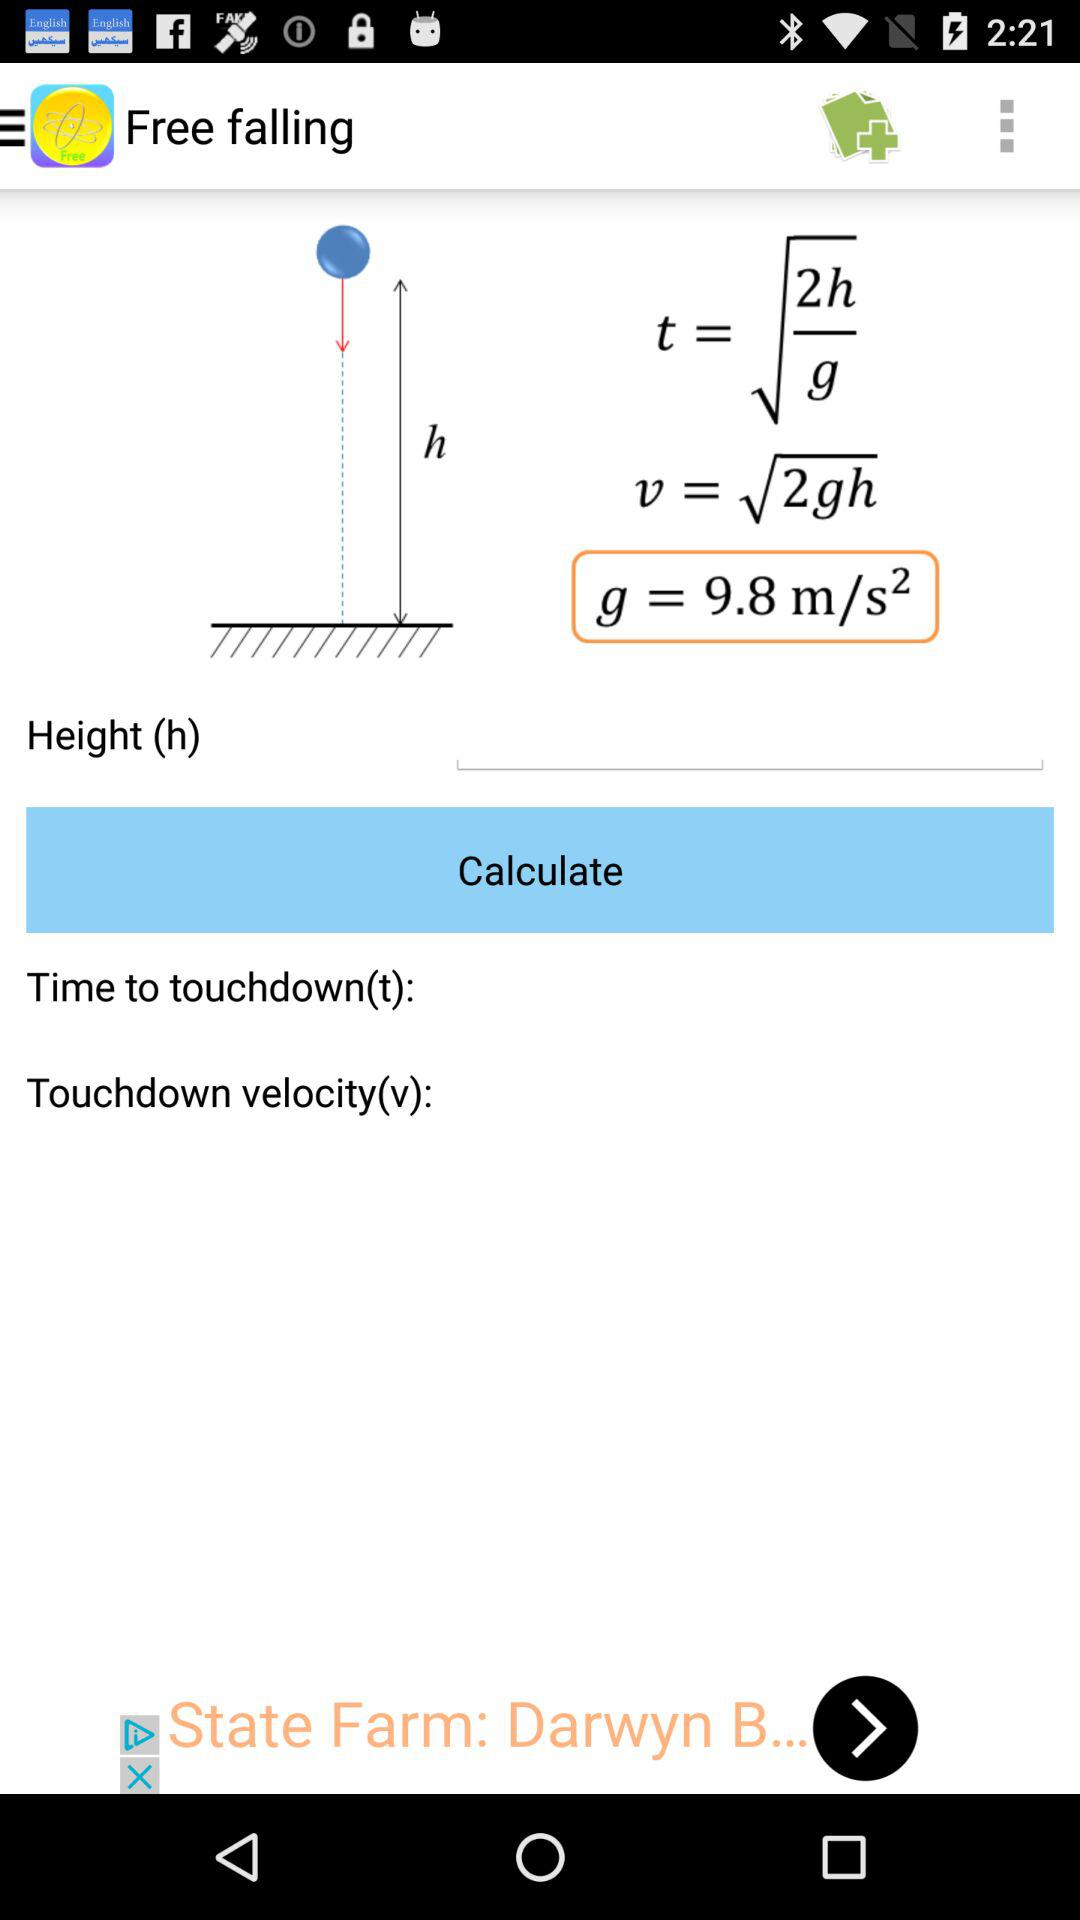What is the formula for the touchdown velocity of the balloon?
Answer the question using a single word or phrase. V = √2gh 